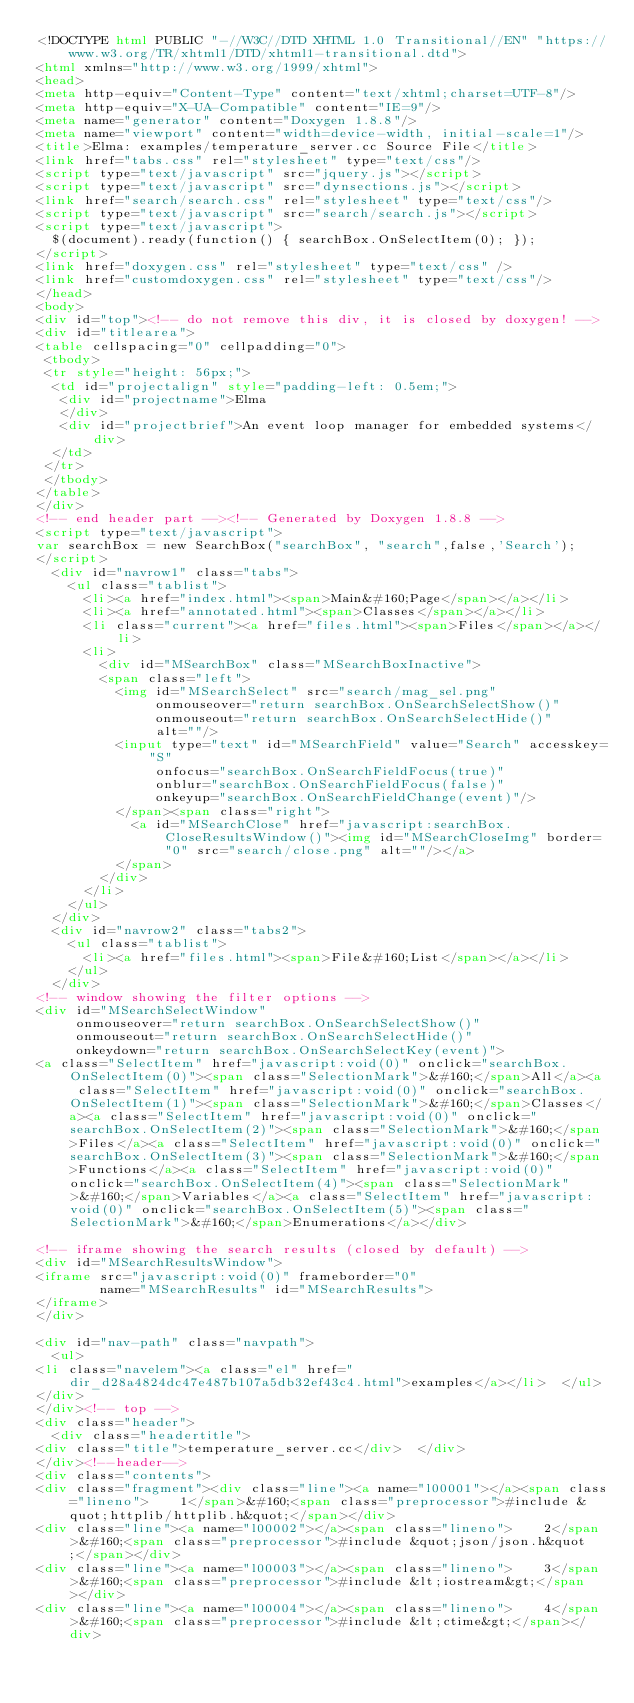<code> <loc_0><loc_0><loc_500><loc_500><_HTML_><!DOCTYPE html PUBLIC "-//W3C//DTD XHTML 1.0 Transitional//EN" "https://www.w3.org/TR/xhtml1/DTD/xhtml1-transitional.dtd">
<html xmlns="http://www.w3.org/1999/xhtml">
<head>
<meta http-equiv="Content-Type" content="text/xhtml;charset=UTF-8"/>
<meta http-equiv="X-UA-Compatible" content="IE=9"/>
<meta name="generator" content="Doxygen 1.8.8"/>
<meta name="viewport" content="width=device-width, initial-scale=1"/>
<title>Elma: examples/temperature_server.cc Source File</title>
<link href="tabs.css" rel="stylesheet" type="text/css"/>
<script type="text/javascript" src="jquery.js"></script>
<script type="text/javascript" src="dynsections.js"></script>
<link href="search/search.css" rel="stylesheet" type="text/css"/>
<script type="text/javascript" src="search/search.js"></script>
<script type="text/javascript">
  $(document).ready(function() { searchBox.OnSelectItem(0); });
</script>
<link href="doxygen.css" rel="stylesheet" type="text/css" />
<link href="customdoxygen.css" rel="stylesheet" type="text/css"/>
</head>
<body>
<div id="top"><!-- do not remove this div, it is closed by doxygen! -->
<div id="titlearea">
<table cellspacing="0" cellpadding="0">
 <tbody>
 <tr style="height: 56px;">
  <td id="projectalign" style="padding-left: 0.5em;">
   <div id="projectname">Elma
   </div>
   <div id="projectbrief">An event loop manager for embedded systems</div>
  </td>
 </tr>
 </tbody>
</table>
</div>
<!-- end header part --><!-- Generated by Doxygen 1.8.8 -->
<script type="text/javascript">
var searchBox = new SearchBox("searchBox", "search",false,'Search');
</script>
  <div id="navrow1" class="tabs">
    <ul class="tablist">
      <li><a href="index.html"><span>Main&#160;Page</span></a></li>
      <li><a href="annotated.html"><span>Classes</span></a></li>
      <li class="current"><a href="files.html"><span>Files</span></a></li>
      <li>
        <div id="MSearchBox" class="MSearchBoxInactive">
        <span class="left">
          <img id="MSearchSelect" src="search/mag_sel.png"
               onmouseover="return searchBox.OnSearchSelectShow()"
               onmouseout="return searchBox.OnSearchSelectHide()"
               alt=""/>
          <input type="text" id="MSearchField" value="Search" accesskey="S"
               onfocus="searchBox.OnSearchFieldFocus(true)" 
               onblur="searchBox.OnSearchFieldFocus(false)" 
               onkeyup="searchBox.OnSearchFieldChange(event)"/>
          </span><span class="right">
            <a id="MSearchClose" href="javascript:searchBox.CloseResultsWindow()"><img id="MSearchCloseImg" border="0" src="search/close.png" alt=""/></a>
          </span>
        </div>
      </li>
    </ul>
  </div>
  <div id="navrow2" class="tabs2">
    <ul class="tablist">
      <li><a href="files.html"><span>File&#160;List</span></a></li>
    </ul>
  </div>
<!-- window showing the filter options -->
<div id="MSearchSelectWindow"
     onmouseover="return searchBox.OnSearchSelectShow()"
     onmouseout="return searchBox.OnSearchSelectHide()"
     onkeydown="return searchBox.OnSearchSelectKey(event)">
<a class="SelectItem" href="javascript:void(0)" onclick="searchBox.OnSelectItem(0)"><span class="SelectionMark">&#160;</span>All</a><a class="SelectItem" href="javascript:void(0)" onclick="searchBox.OnSelectItem(1)"><span class="SelectionMark">&#160;</span>Classes</a><a class="SelectItem" href="javascript:void(0)" onclick="searchBox.OnSelectItem(2)"><span class="SelectionMark">&#160;</span>Files</a><a class="SelectItem" href="javascript:void(0)" onclick="searchBox.OnSelectItem(3)"><span class="SelectionMark">&#160;</span>Functions</a><a class="SelectItem" href="javascript:void(0)" onclick="searchBox.OnSelectItem(4)"><span class="SelectionMark">&#160;</span>Variables</a><a class="SelectItem" href="javascript:void(0)" onclick="searchBox.OnSelectItem(5)"><span class="SelectionMark">&#160;</span>Enumerations</a></div>

<!-- iframe showing the search results (closed by default) -->
<div id="MSearchResultsWindow">
<iframe src="javascript:void(0)" frameborder="0" 
        name="MSearchResults" id="MSearchResults">
</iframe>
</div>

<div id="nav-path" class="navpath">
  <ul>
<li class="navelem"><a class="el" href="dir_d28a4824dc47e487b107a5db32ef43c4.html">examples</a></li>  </ul>
</div>
</div><!-- top -->
<div class="header">
  <div class="headertitle">
<div class="title">temperature_server.cc</div>  </div>
</div><!--header-->
<div class="contents">
<div class="fragment"><div class="line"><a name="l00001"></a><span class="lineno">    1</span>&#160;<span class="preprocessor">#include &quot;httplib/httplib.h&quot;</span></div>
<div class="line"><a name="l00002"></a><span class="lineno">    2</span>&#160;<span class="preprocessor">#include &quot;json/json.h&quot;</span></div>
<div class="line"><a name="l00003"></a><span class="lineno">    3</span>&#160;<span class="preprocessor">#include &lt;iostream&gt;</span></div>
<div class="line"><a name="l00004"></a><span class="lineno">    4</span>&#160;<span class="preprocessor">#include &lt;ctime&gt;</span></div></code> 